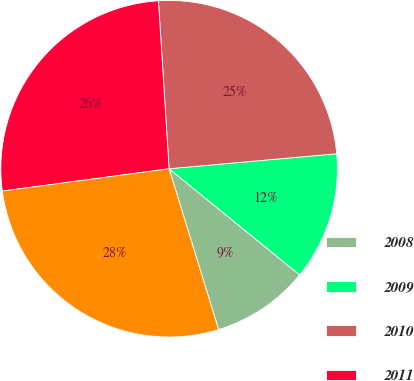<chart> <loc_0><loc_0><loc_500><loc_500><pie_chart><fcel>2008<fcel>2009<fcel>2010<fcel>2011<fcel>2012<nl><fcel>9.38%<fcel>12.29%<fcel>24.59%<fcel>26.11%<fcel>27.63%<nl></chart> 